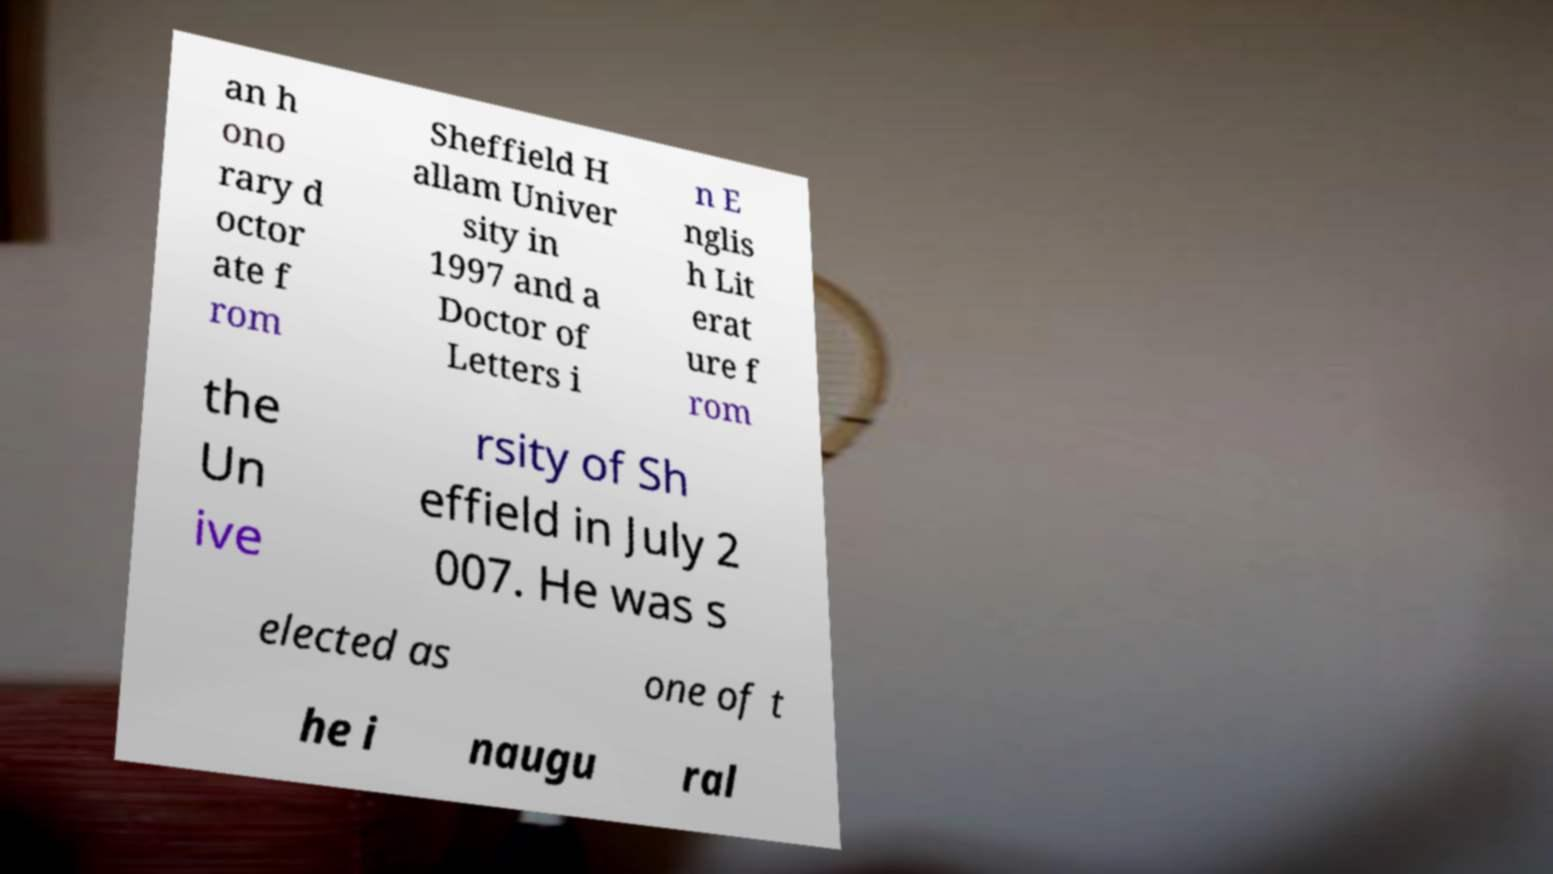Can you read and provide the text displayed in the image?This photo seems to have some interesting text. Can you extract and type it out for me? an h ono rary d octor ate f rom Sheffield H allam Univer sity in 1997 and a Doctor of Letters i n E nglis h Lit erat ure f rom the Un ive rsity of Sh effield in July 2 007. He was s elected as one of t he i naugu ral 